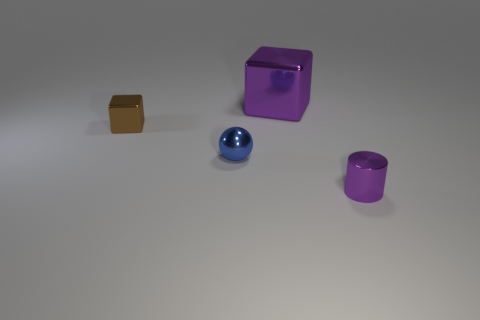Is the material of the brown cube the same as the object that is behind the tiny brown cube?
Provide a short and direct response. Yes. Are there the same number of metallic objects that are in front of the small shiny cube and tiny shiny objects in front of the small cylinder?
Your answer should be compact. No. Do the brown shiny thing and the blue shiny thing in front of the big block have the same size?
Your response must be concise. Yes. Are there more small cylinders that are behind the sphere than tiny blue cylinders?
Provide a short and direct response. No. How many shiny objects are the same size as the brown block?
Make the answer very short. 2. There is a purple metallic thing to the left of the small purple metal cylinder; is its size the same as the purple shiny thing that is in front of the brown thing?
Provide a succinct answer. No. Is the number of spheres on the right side of the blue sphere greater than the number of large cubes that are in front of the purple shiny cube?
Ensure brevity in your answer.  No. What number of small brown objects are the same shape as the large object?
Provide a succinct answer. 1. What material is the ball that is the same size as the purple metal cylinder?
Your answer should be compact. Metal. Is there a purple cylinder that has the same material as the small brown thing?
Keep it short and to the point. Yes. 